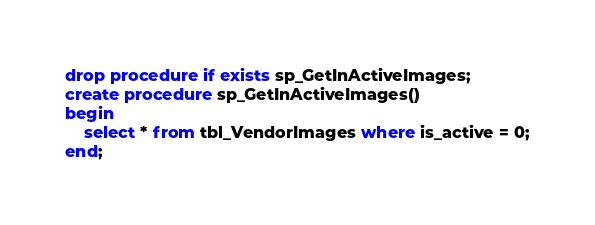Convert code to text. <code><loc_0><loc_0><loc_500><loc_500><_SQL_>drop procedure if exists sp_GetInActiveImages;
create procedure sp_GetInActiveImages()
begin
    select * from tbl_VendorImages where is_active = 0;
end;</code> 